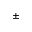Convert formula to latex. <formula><loc_0><loc_0><loc_500><loc_500>\pm</formula> 